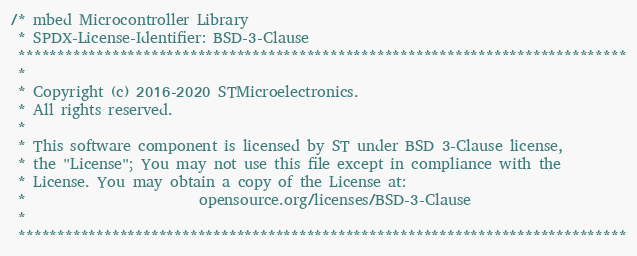Convert code to text. <code><loc_0><loc_0><loc_500><loc_500><_C_>/* mbed Microcontroller Library
 * SPDX-License-Identifier: BSD-3-Clause
 ******************************************************************************
 *
 * Copyright (c) 2016-2020 STMicroelectronics.
 * All rights reserved.
 *
 * This software component is licensed by ST under BSD 3-Clause license,
 * the "License"; You may not use this file except in compliance with the
 * License. You may obtain a copy of the License at:
 *                        opensource.org/licenses/BSD-3-Clause
 *
 ******************************************************************************
</code> 